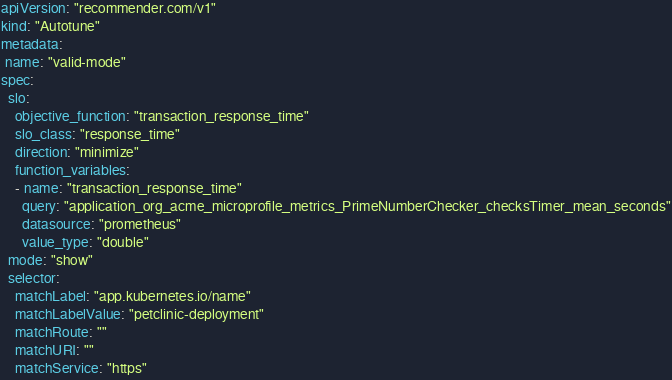<code> <loc_0><loc_0><loc_500><loc_500><_YAML_>apiVersion: "recommender.com/v1"
kind: "Autotune"
metadata:
 name: "valid-mode"
spec:
  slo:
    objective_function: "transaction_response_time"
    slo_class: "response_time"
    direction: "minimize"
    function_variables:
    - name: "transaction_response_time"
      query: "application_org_acme_microprofile_metrics_PrimeNumberChecker_checksTimer_mean_seconds"
      datasource: "prometheus"
      value_type: "double"
  mode: "show"
  selector:
    matchLabel: "app.kubernetes.io/name"
    matchLabelValue: "petclinic-deployment"
    matchRoute: ""
    matchURI: ""
    matchService: "https"
</code> 